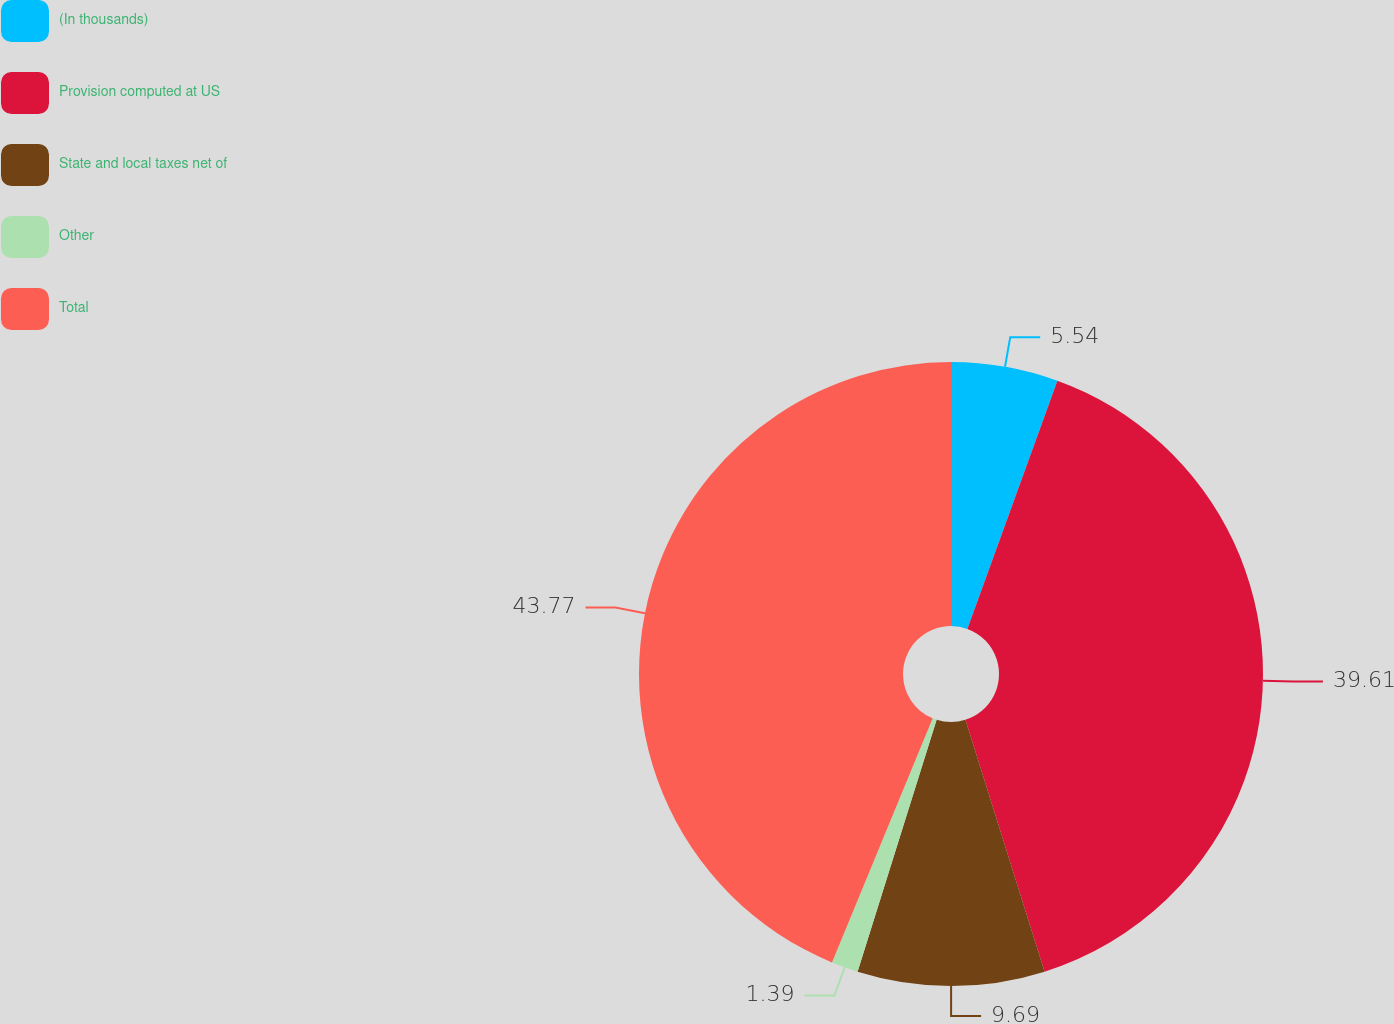Convert chart. <chart><loc_0><loc_0><loc_500><loc_500><pie_chart><fcel>(In thousands)<fcel>Provision computed at US<fcel>State and local taxes net of<fcel>Other<fcel>Total<nl><fcel>5.54%<fcel>39.61%<fcel>9.69%<fcel>1.39%<fcel>43.77%<nl></chart> 